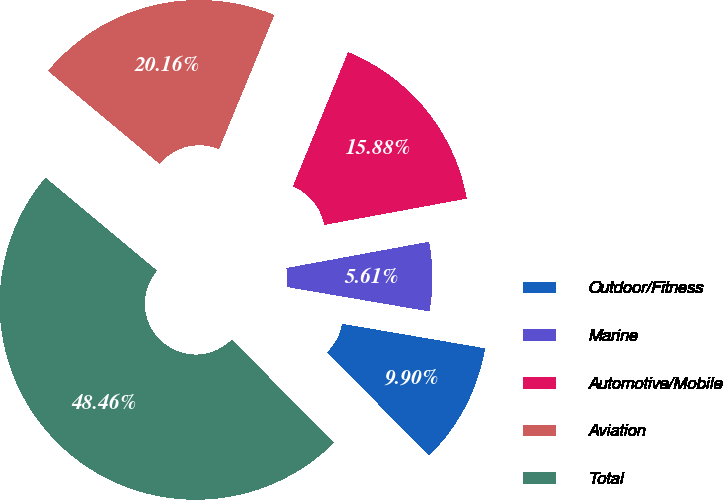Convert chart. <chart><loc_0><loc_0><loc_500><loc_500><pie_chart><fcel>Outdoor/Fitness<fcel>Marine<fcel>Automotive/Mobile<fcel>Aviation<fcel>Total<nl><fcel>9.9%<fcel>5.61%<fcel>15.88%<fcel>20.16%<fcel>48.46%<nl></chart> 